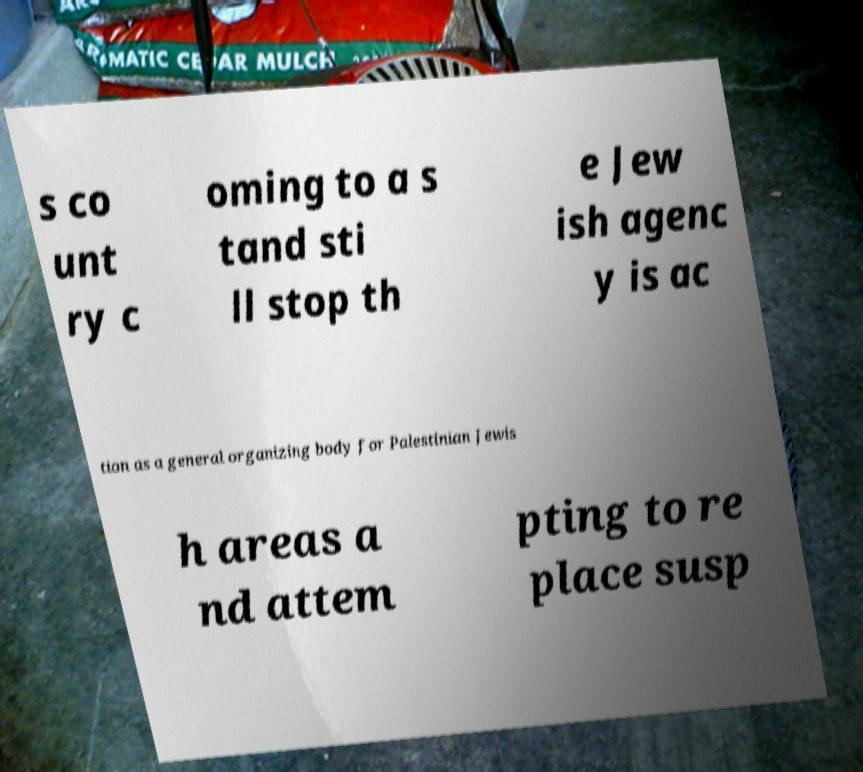Can you read and provide the text displayed in the image?This photo seems to have some interesting text. Can you extract and type it out for me? s co unt ry c oming to a s tand sti ll stop th e Jew ish agenc y is ac tion as a general organizing body for Palestinian Jewis h areas a nd attem pting to re place susp 